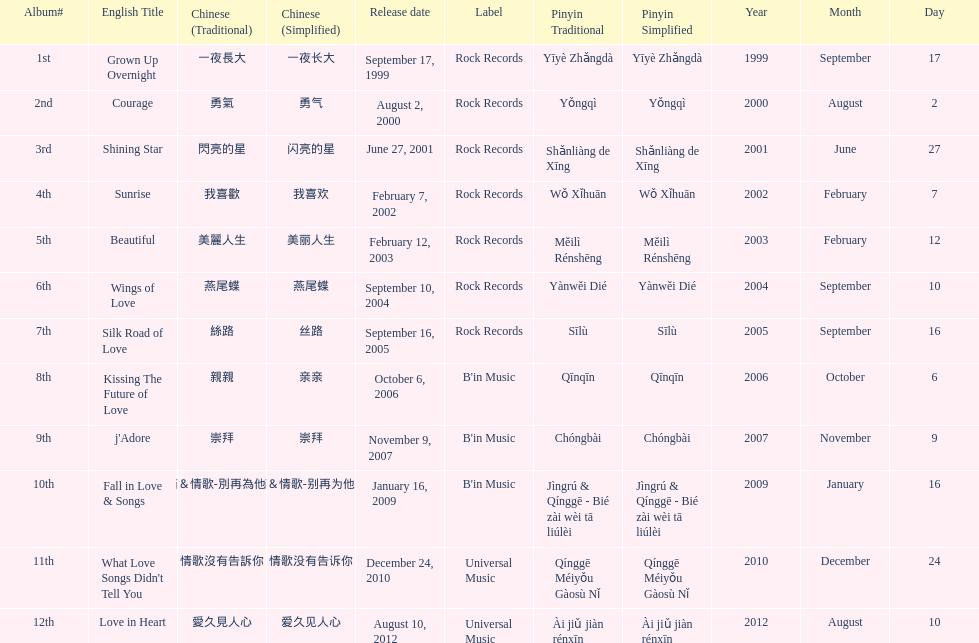Which song is listed first in the table? Grown Up Overnight. 